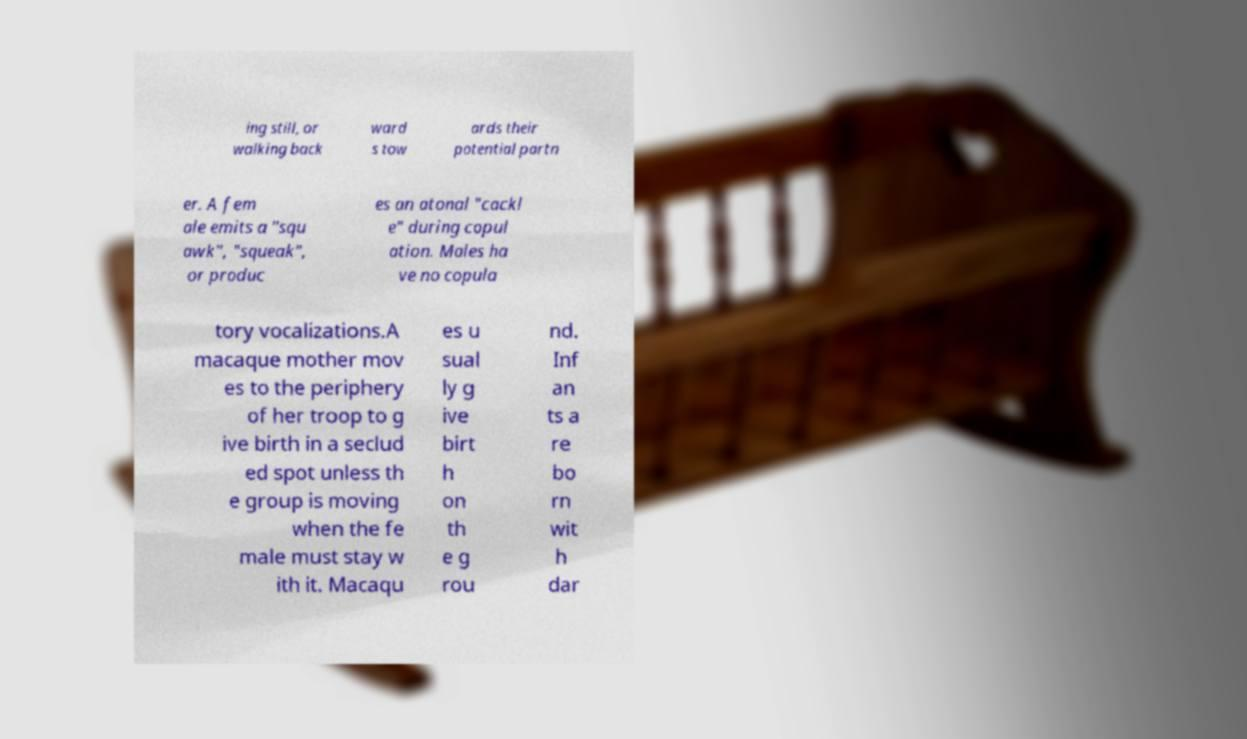Can you accurately transcribe the text from the provided image for me? ing still, or walking back ward s tow ards their potential partn er. A fem ale emits a "squ awk", "squeak", or produc es an atonal "cackl e" during copul ation. Males ha ve no copula tory vocalizations.A macaque mother mov es to the periphery of her troop to g ive birth in a seclud ed spot unless th e group is moving when the fe male must stay w ith it. Macaqu es u sual ly g ive birt h on th e g rou nd. Inf an ts a re bo rn wit h dar 